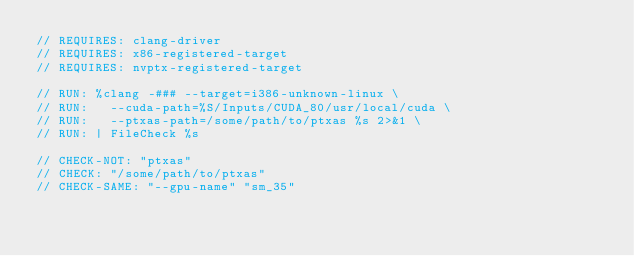Convert code to text. <code><loc_0><loc_0><loc_500><loc_500><_Cuda_>// REQUIRES: clang-driver
// REQUIRES: x86-registered-target
// REQUIRES: nvptx-registered-target

// RUN: %clang -### --target=i386-unknown-linux \
// RUN:   --cuda-path=%S/Inputs/CUDA_80/usr/local/cuda \
// RUN:   --ptxas-path=/some/path/to/ptxas %s 2>&1 \
// RUN: | FileCheck %s

// CHECK-NOT: "ptxas"
// CHECK: "/some/path/to/ptxas"
// CHECK-SAME: "--gpu-name" "sm_35"
</code> 